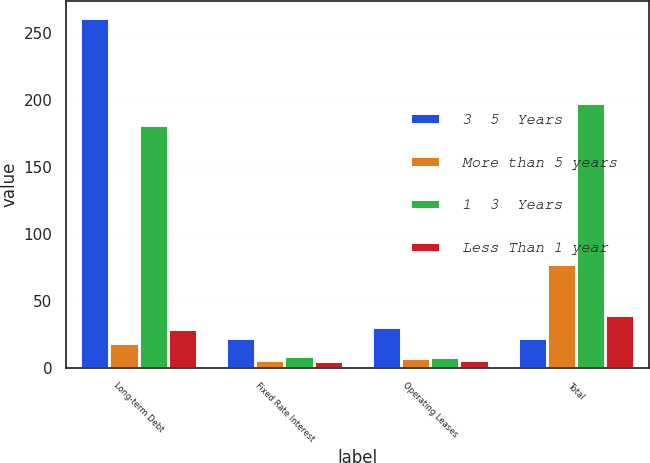<chart> <loc_0><loc_0><loc_500><loc_500><stacked_bar_chart><ecel><fcel>Long-term Debt<fcel>Fixed Rate Interest<fcel>Operating Leases<fcel>Total<nl><fcel>3  5  Years<fcel>261<fcel>22.4<fcel>30.2<fcel>22.4<nl><fcel>More than 5 years<fcel>18.6<fcel>6.1<fcel>7.2<fcel>77.4<nl><fcel>1  3  Years<fcel>181.2<fcel>9<fcel>7.9<fcel>198.1<nl><fcel>Less Than 1 year<fcel>29.2<fcel>5.1<fcel>5.4<fcel>39.7<nl></chart> 